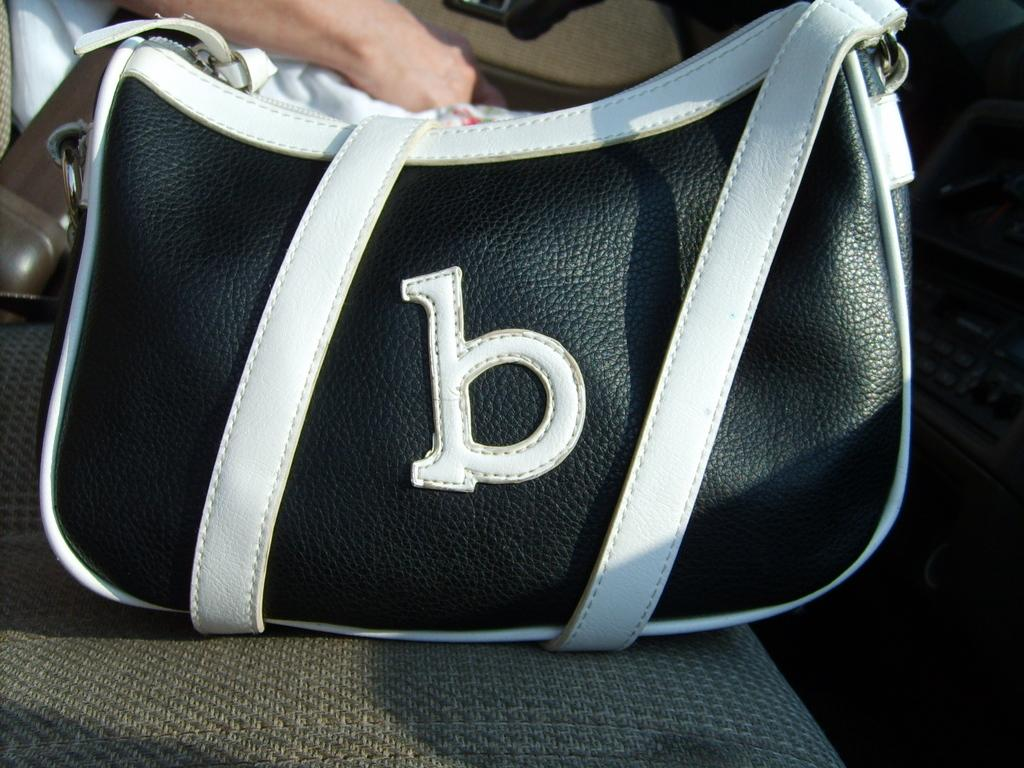What is the main subject of the image? The main subject of the image is a handbag. What colors are used to depict the handbag? The handbag is in black and white colors. Where is the handbag located in the image? The handbag is on a chair. Can you describe the setting of the image? There is a person sitting in the background of the image. What type of crow can be seen sitting on the plough in the image? There is no crow or plough present in the image; it features a handbag on a chair and a person sitting in the background. 